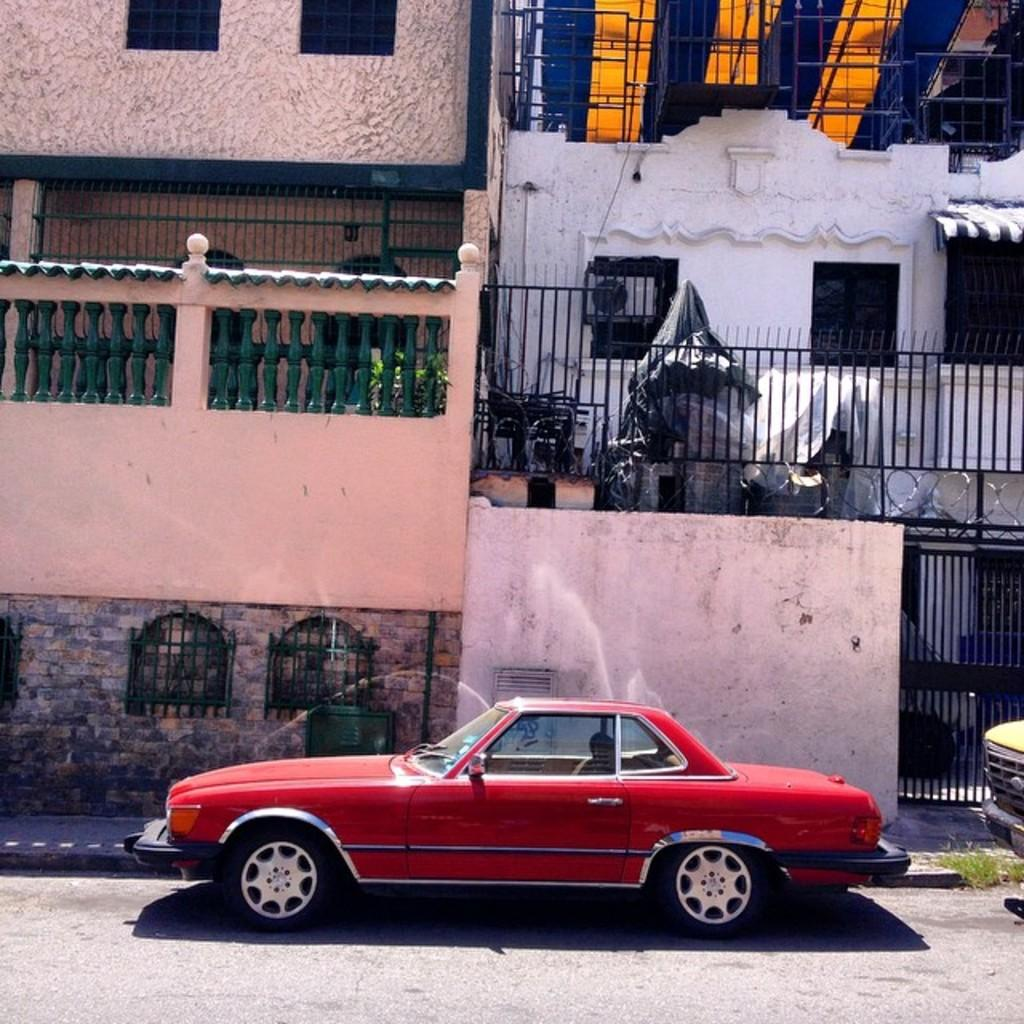What type of structures can be seen in the image? There are buildings in the image. What feature is common to many of the buildings in the image? There are windows in the image. What architectural element is present in the image? There is a grille in the image. What type of barrier is visible in the image? There is a wall in the image. What type of objects are on the ground in the image? There are vehicles on the ground in the image. Where are the friends sitting in the image? There are no friends present in the image. What type of sign can be seen hanging from the wall in the image? There is no sign hanging from the wall in the image. 